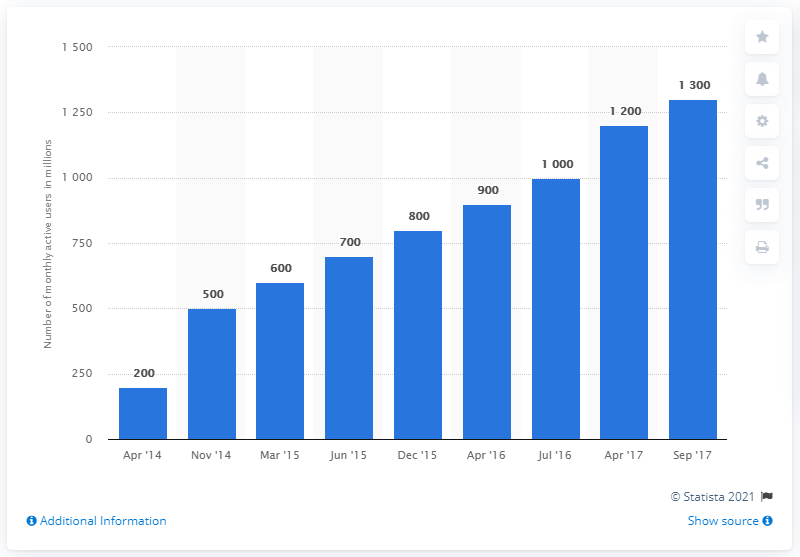Give some essential details in this illustration. In September 2021, Facebook Messenger had approximately 1,300 monthly active users worldwide. 